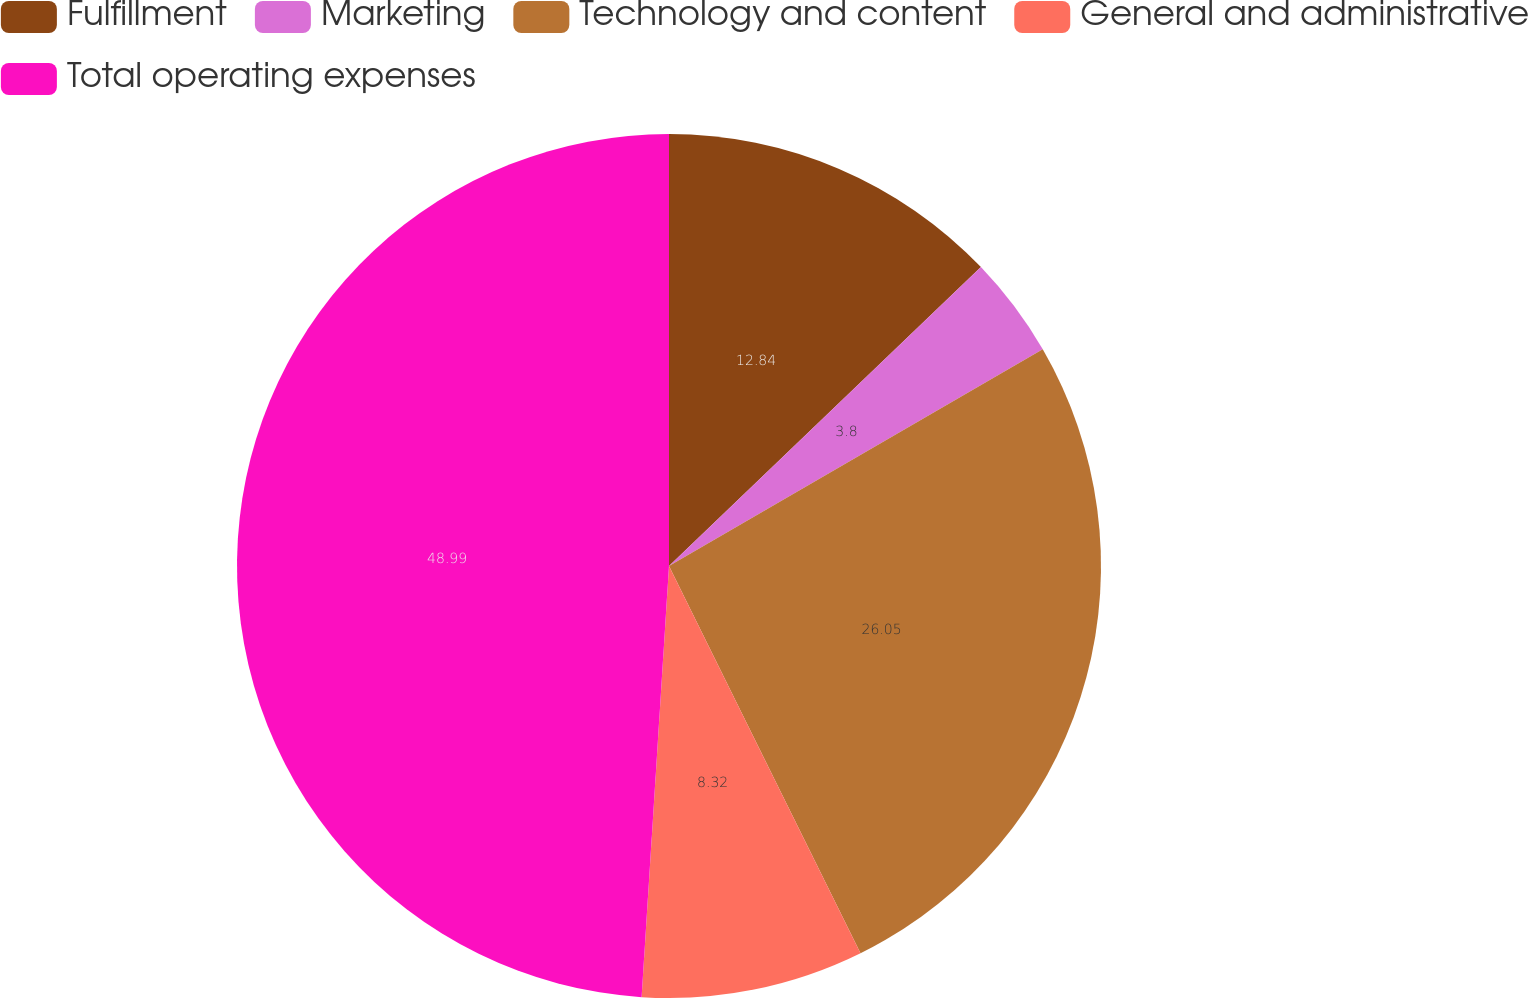Convert chart to OTSL. <chart><loc_0><loc_0><loc_500><loc_500><pie_chart><fcel>Fulfillment<fcel>Marketing<fcel>Technology and content<fcel>General and administrative<fcel>Total operating expenses<nl><fcel>12.84%<fcel>3.8%<fcel>26.05%<fcel>8.32%<fcel>48.99%<nl></chart> 